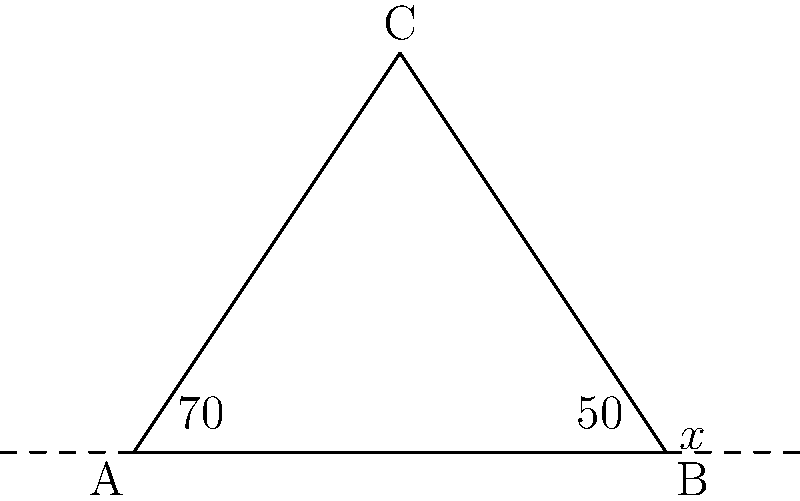In the triangle ABC shown above, two interior angles are given: $\angle BAC = 70°$ and $\angle ABC = 50°$. Calculate the measure of the exterior angle at vertex B, denoted as $x°$. To find the exterior angle at vertex B, we can follow these steps:

1) First, recall that the sum of interior angles of a triangle is always 180°.

2) We are given two interior angles: $\angle BAC = 70°$ and $\angle ABC = 50°$

3) Let's find the third interior angle, $\angle BCA$:
   $\angle BCA = 180° - (70° + 50°) = 180° - 120° = 60°$

4) Now, remember that an exterior angle of a triangle is supplementary to the interior angle at the same vertex. This means they add up to 180°.

5) The exterior angle at B (let's call it $x°$) and the interior angle at B ($\angle ABC = 50°$) should sum to 180°.

6) We can write this as an equation:
   $x° + 50° = 180°$

7) Solving for $x$:
   $x° = 180° - 50° = 130°$

Therefore, the measure of the exterior angle at vertex B is 130°.
Answer: $130°$ 